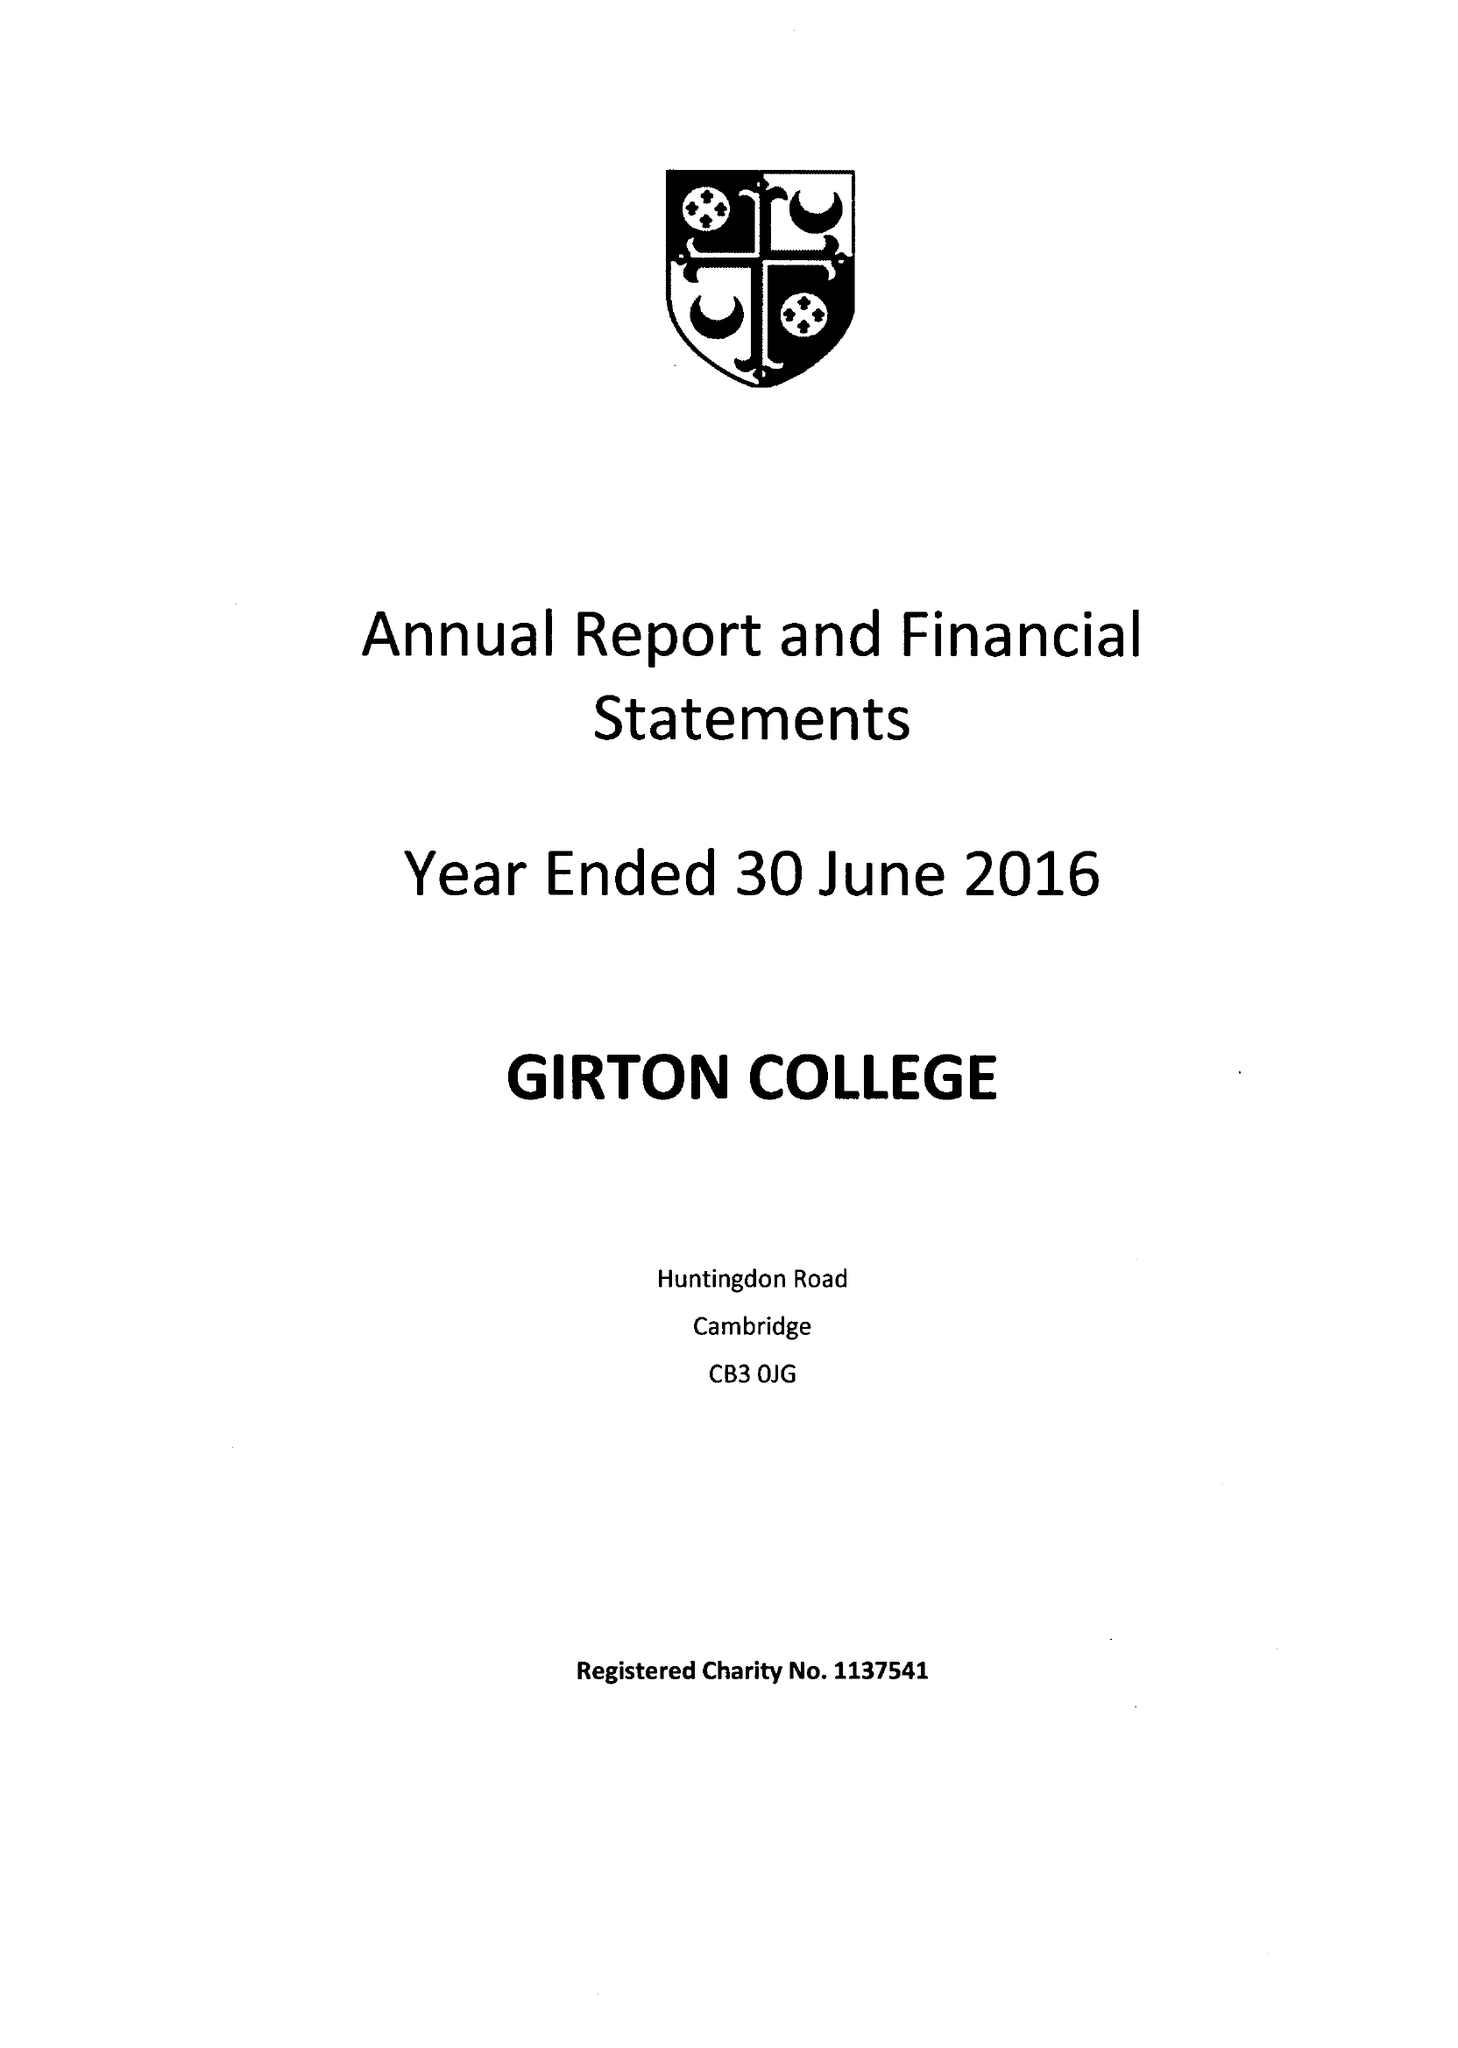What is the value for the charity_number?
Answer the question using a single word or phrase. 1137541 